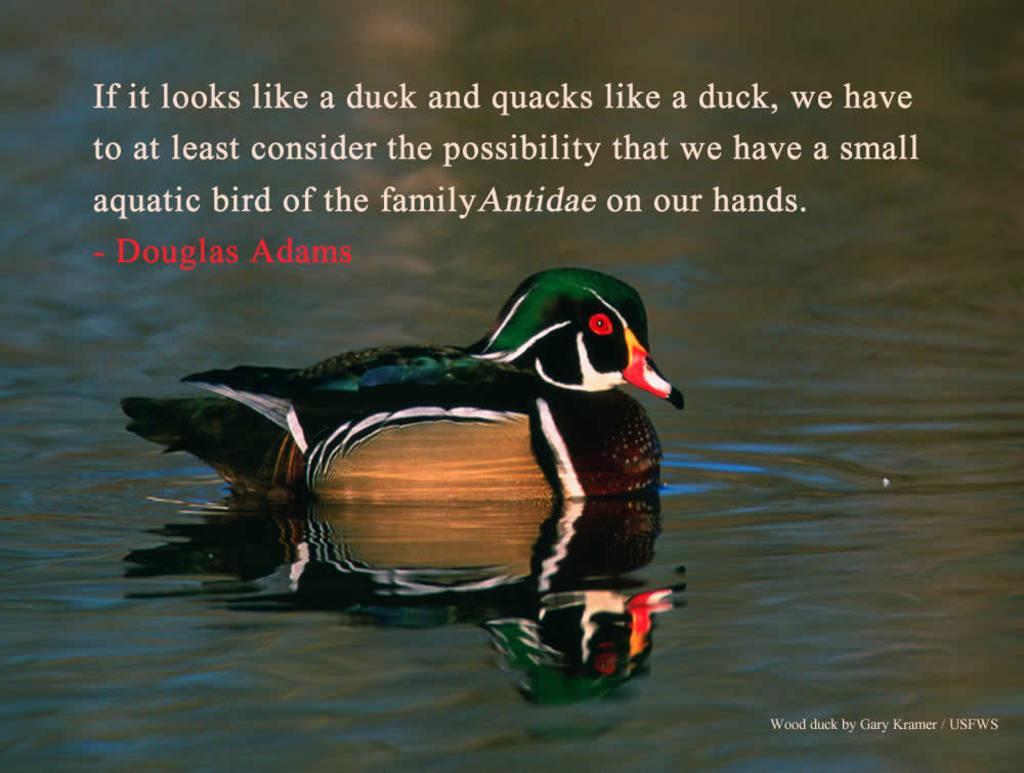How would you summarize this image in a sentence or two? In this image I can see the bird in the water. I can see the bird is in black, white, green, brown, red, and yellow color. I can see something is written on the image. 